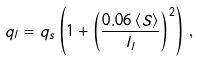<formula> <loc_0><loc_0><loc_500><loc_500>q _ { l } = q _ { s } \left ( 1 + \left ( \frac { 0 . 0 6 \left \langle S \right \rangle } { l _ { l } } \right ) ^ { 2 } \right ) \, ,</formula> 